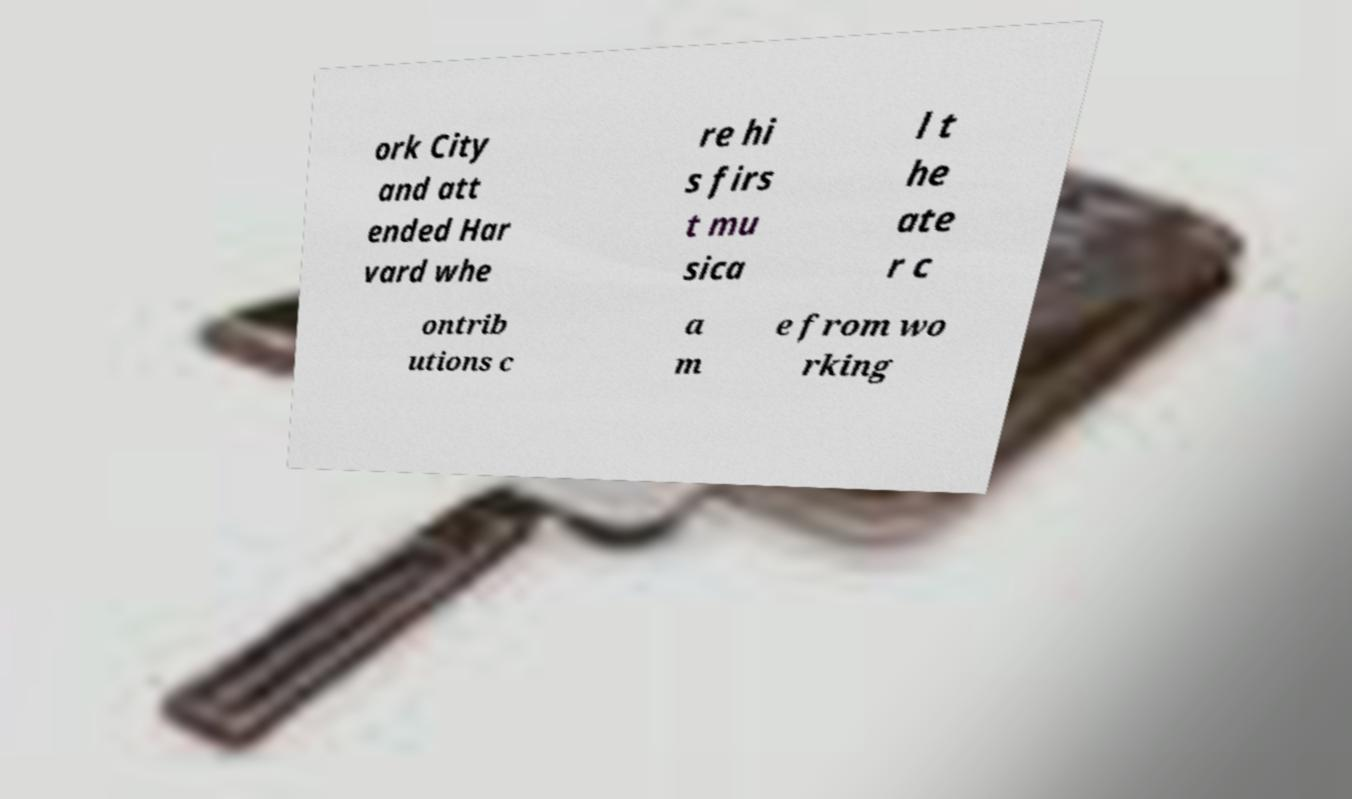I need the written content from this picture converted into text. Can you do that? ork City and att ended Har vard whe re hi s firs t mu sica l t he ate r c ontrib utions c a m e from wo rking 